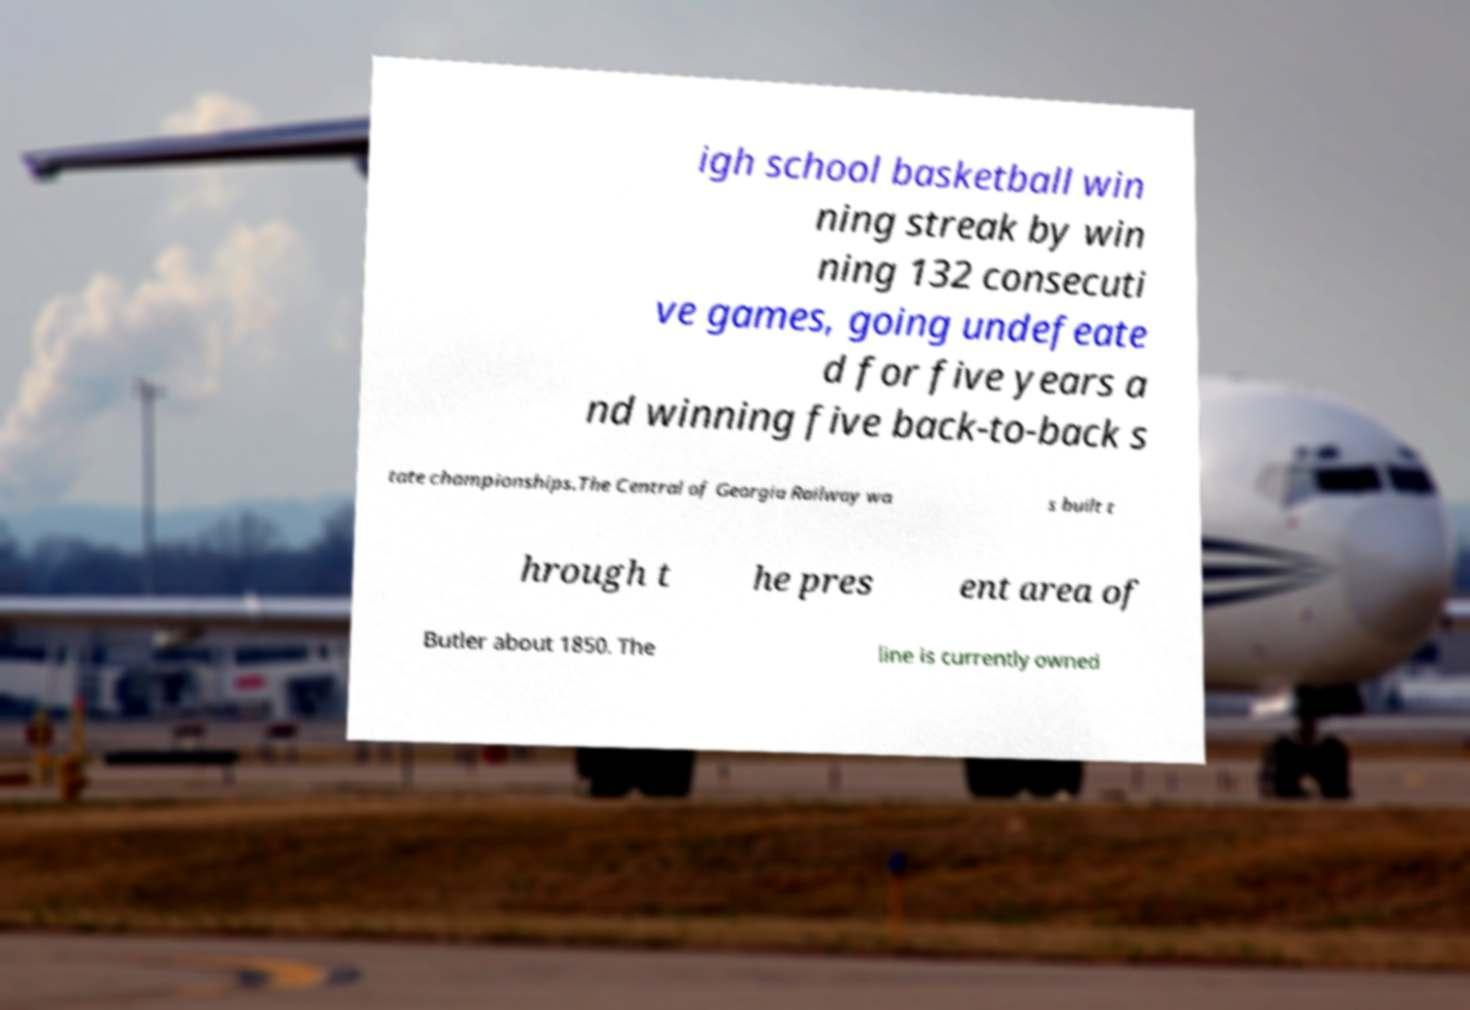Can you accurately transcribe the text from the provided image for me? igh school basketball win ning streak by win ning 132 consecuti ve games, going undefeate d for five years a nd winning five back-to-back s tate championships.The Central of Georgia Railway wa s built t hrough t he pres ent area of Butler about 1850. The line is currently owned 